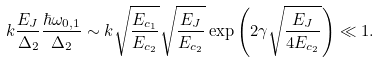<formula> <loc_0><loc_0><loc_500><loc_500>k \frac { E _ { J } } { \Delta _ { 2 } } \frac { \hbar { \omega } _ { 0 , 1 } } { \Delta _ { 2 } } \sim k \sqrt { \frac { E _ { c _ { 1 } } } { E _ { c _ { 2 } } } } \sqrt { \frac { E _ { J } } { E _ { c _ { 2 } } } } \exp \left ( 2 \gamma \sqrt { \frac { E _ { J } } { 4 E _ { c _ { 2 } } } } \right ) \ll 1 .</formula> 